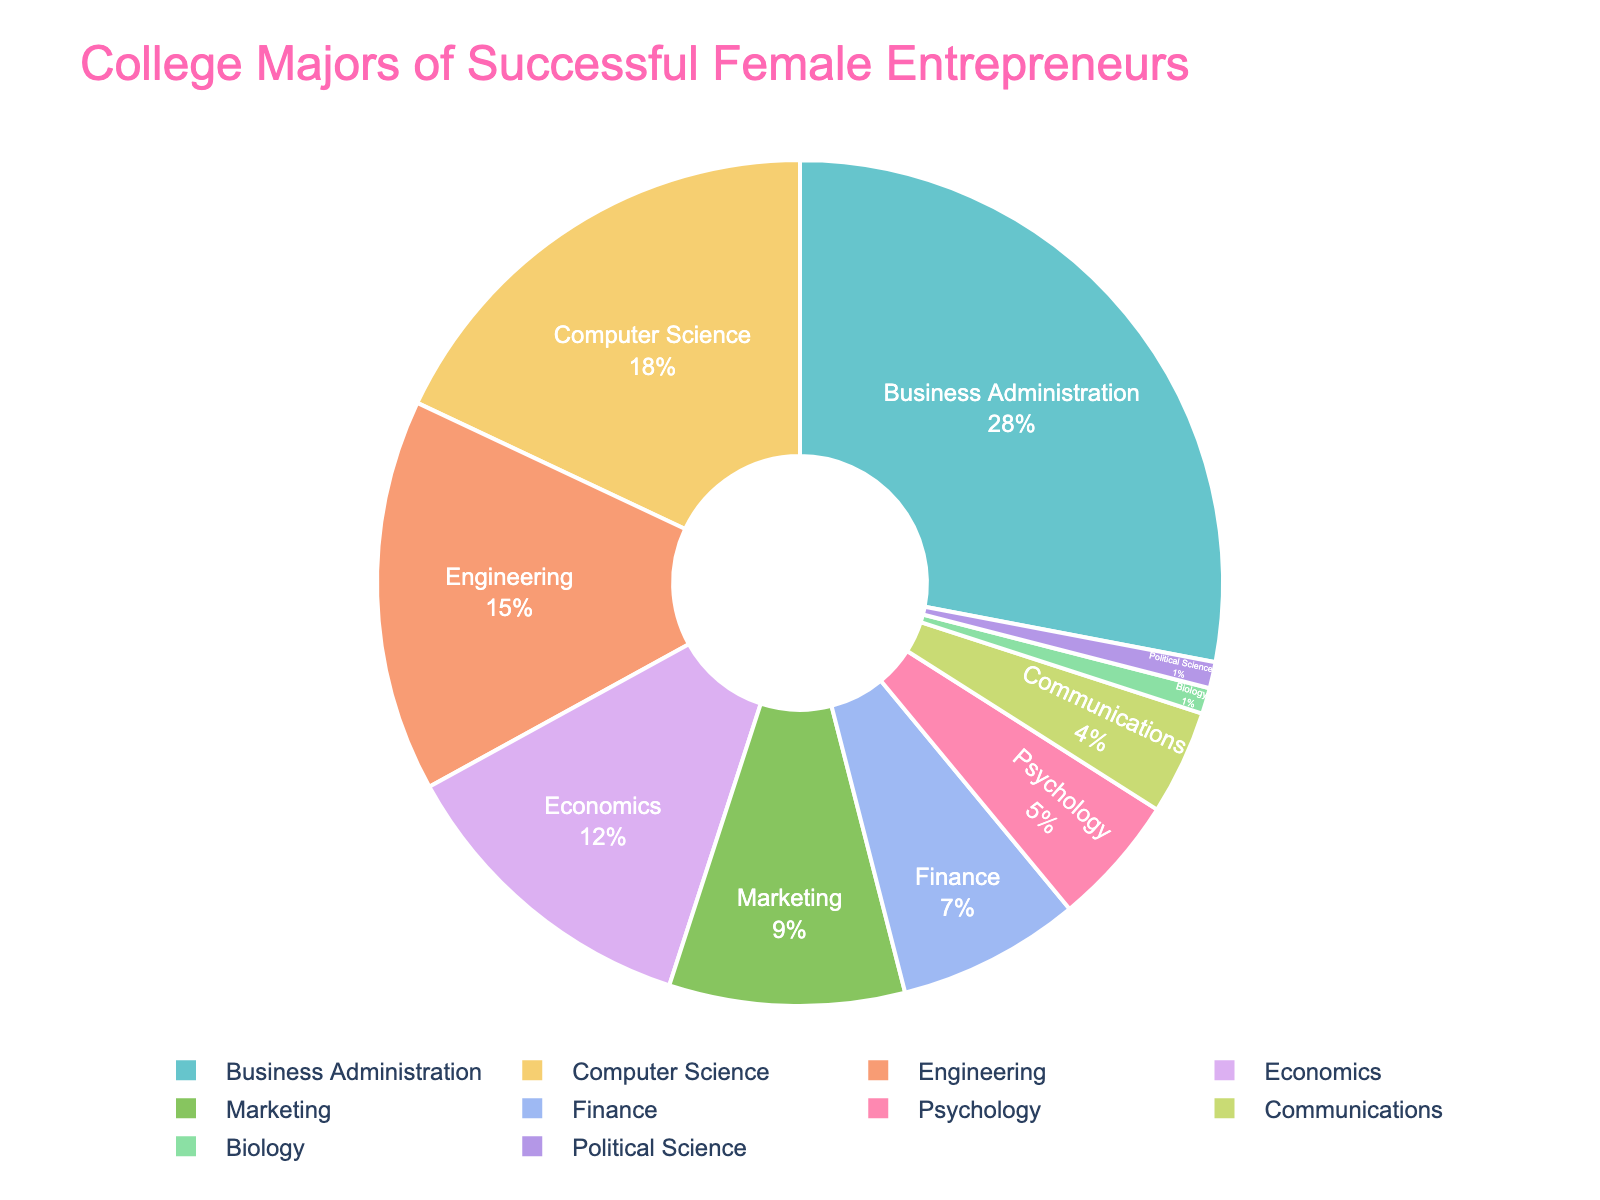What percentage of successful female entrepreneurs chose Business Administration as their major? Look at the pie chart and find the segment labeled "Business Administration". The label should indicate both the major and the percentage.
Answer: 28% Which major has a higher percentage: Computer Science or Engineering? Compare the segments labeled "Computer Science" and "Engineering" in the pie chart. Check their associated percentages.
Answer: Computer Science What is the combined percentage of successful female entrepreneurs who majored in Economics, Finance, and Marketing? Locate the segments labeled "Economics", "Finance", and "Marketing". Sum their percentages: 12 + 7 + 9.
Answer: 28% Which three majors have the smallest percentages, and what are their combined percentage? Identify the smallest segments by examining the pie chart. The majors with the smallest percentages are "Communications", "Biology", and "Political Science". Their combined percentages are 4 + 1 + 1.
Answer: Communications, Biology, and Political Science, 6% What is the difference in percentage between the major with the highest percentage and the major with the lowest percentage? Identify the major with the highest (Business Administration, 28%) and the major with the lowest percentage (Biology or Political Science, 1%). Subtract the lowest percentage from the highest.
Answer: 27% What percentage of successful female entrepreneurs chose majors related to business (Business Administration, Marketing, Finance)? Sum the percentages of "Business Administration" (28%), "Marketing" (9%), and "Finance" (7%).
Answer: 44% What is the most common major among successful female entrepreneurs? Look for the largest segment in the pie chart which is labeled with the major and percentage.
Answer: Business Administration Which majors have a percentage greater than or equal to 10%? Identify segments in the pie chart with percentages greater than or equal to 10%. These are "Business Administration" (28%), "Computer Science" (18%) and "Engineering" (15%), "Economics" (12%).
Answer: Business Administration, Computer Science, Engineering, Economics What is the total percentage of successful female entrepreneurs who chose STEM majors (Computer Science, Engineering, Biology)? Sum the percentages of "Computer Science" (18%), "Engineering" (15%), and "Biology" (1%).
Answer: 34% How many majors have a percentage lower than 5%? Count the segments in the pie chart with percentages lower than 5%. These segments include "Psychology", "Communications", "Biology", and "Political Science".
Answer: 4 